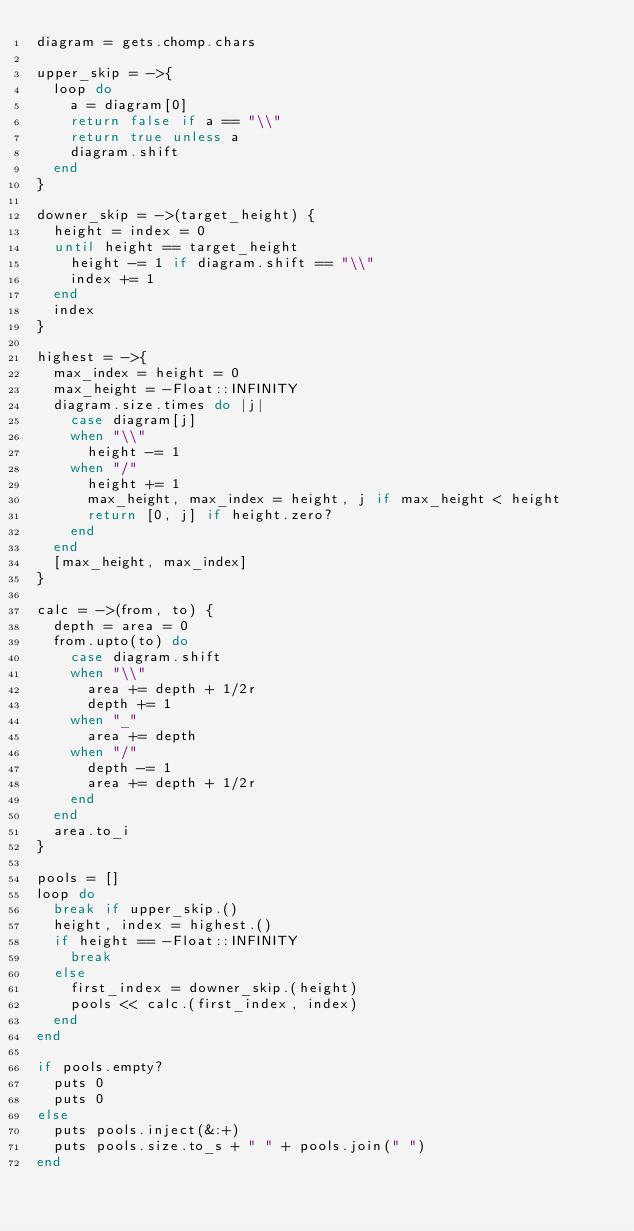<code> <loc_0><loc_0><loc_500><loc_500><_Ruby_>diagram = gets.chomp.chars

upper_skip = ->{
  loop do
    a = diagram[0]
    return false if a == "\\"
    return true unless a
    diagram.shift
  end
}

downer_skip = ->(target_height) {
  height = index = 0
  until height == target_height
    height -= 1 if diagram.shift == "\\"
    index += 1
  end
  index
}

highest = ->{
  max_index = height = 0
  max_height = -Float::INFINITY 
  diagram.size.times do |j|
    case diagram[j]
    when "\\"
      height -= 1
    when "/"
      height += 1
      max_height, max_index = height, j if max_height < height
      return [0, j] if height.zero?
    end
  end
  [max_height, max_index]
}

calc = ->(from, to) {
  depth = area = 0
  from.upto(to) do
    case diagram.shift
    when "\\"
      area += depth + 1/2r
      depth += 1
    when "_"
      area += depth
    when "/"
      depth -= 1
      area += depth + 1/2r
    end
  end
  area.to_i
}

pools = []
loop do
  break if upper_skip.()
  height, index = highest.()
  if height == -Float::INFINITY
    break
  else
    first_index = downer_skip.(height)
    pools << calc.(first_index, index)
  end
end

if pools.empty?
  puts 0
  puts 0
else
  puts pools.inject(&:+)
  puts pools.size.to_s + " " + pools.join(" ")
end
</code> 